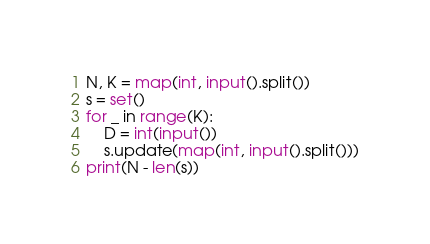Convert code to text. <code><loc_0><loc_0><loc_500><loc_500><_Python_>N, K = map(int, input().split())
s = set()
for _ in range(K):
    D = int(input())
    s.update(map(int, input().split()))
print(N - len(s))
</code> 